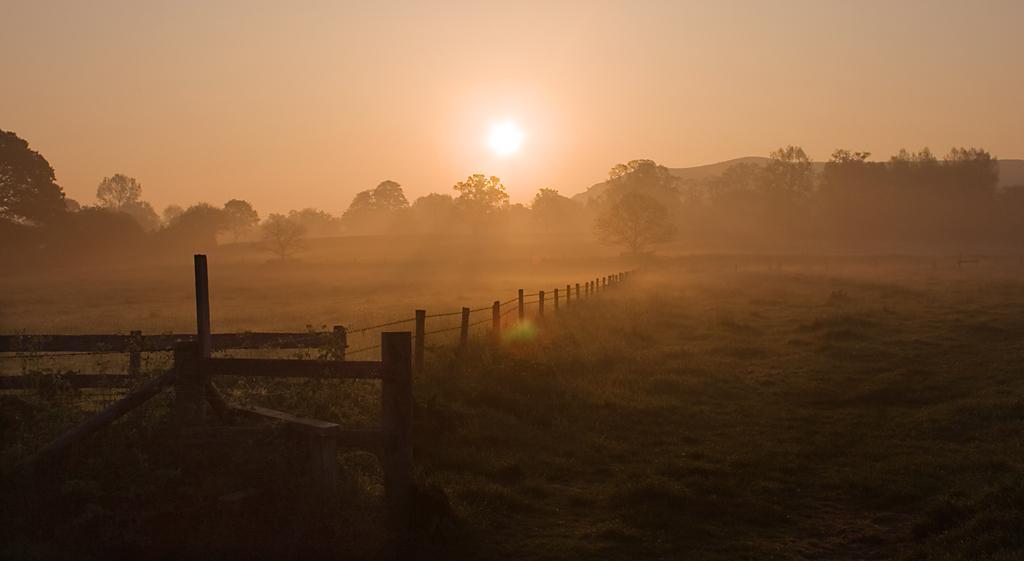Can you describe this image briefly? In this image at the bottom there is grass, and in the center there is a fence and some wooden sticks. And in the background there are some trees, mountains, and at the top there is sky and sun. 